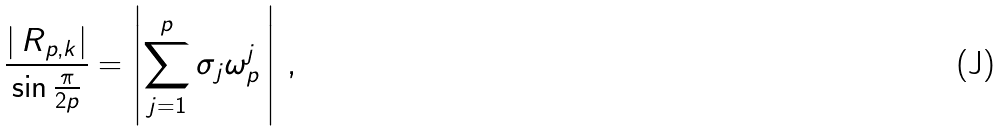Convert formula to latex. <formula><loc_0><loc_0><loc_500><loc_500>\frac { | \, R _ { p , k } | } { \sin \frac { \pi } { 2 p } } = \left | \sum _ { j = 1 } ^ { p } \sigma _ { j } \omega _ { p } ^ { j } \, \right | \, ,</formula> 